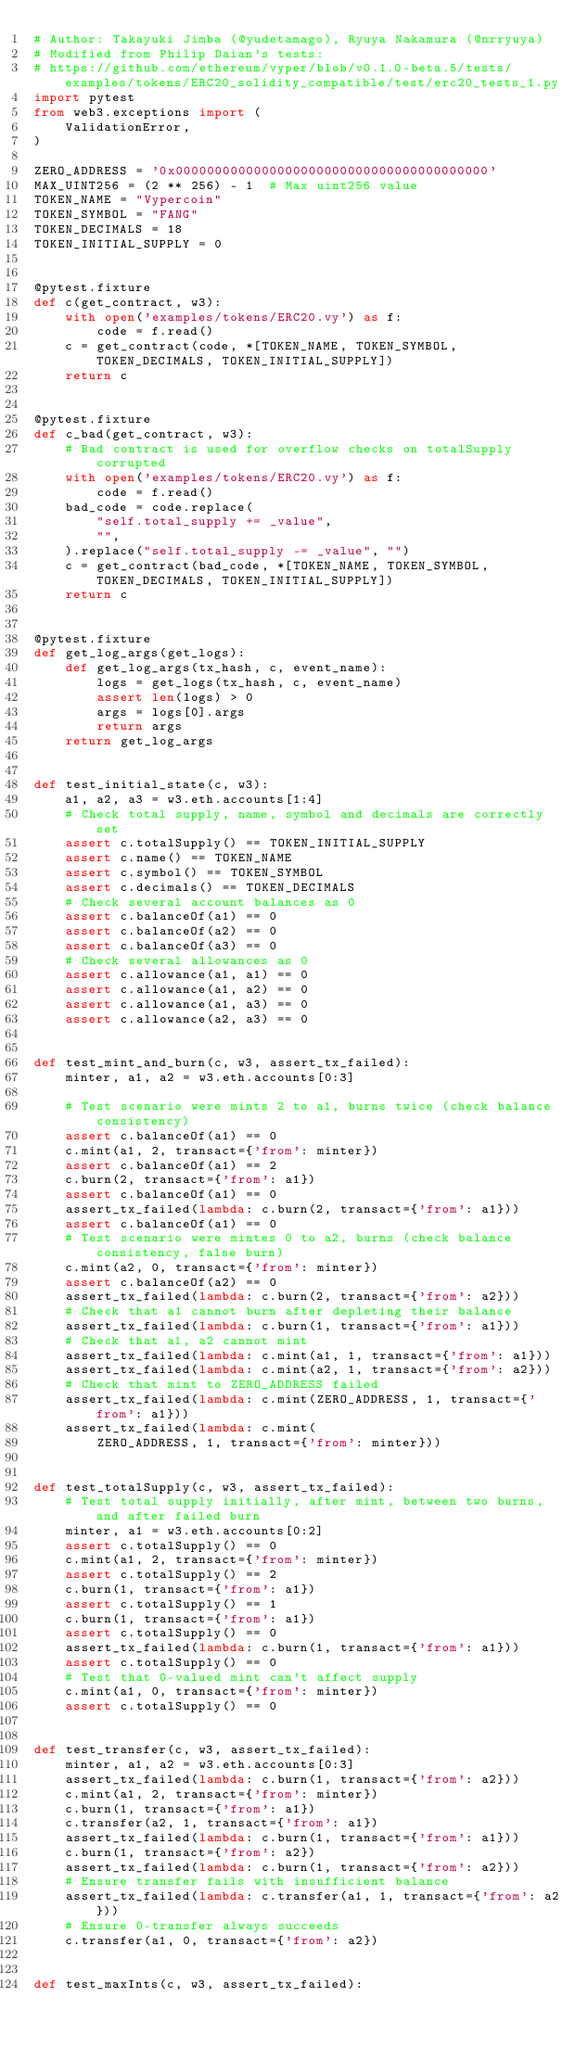<code> <loc_0><loc_0><loc_500><loc_500><_Python_># Author: Takayuki Jimba (@yudetamago), Ryuya Nakamura (@nrryuya)
# Modified from Philip Daian's tests:
# https://github.com/ethereum/vyper/blob/v0.1.0-beta.5/tests/examples/tokens/ERC20_solidity_compatible/test/erc20_tests_1.py
import pytest
from web3.exceptions import (
    ValidationError,
)

ZERO_ADDRESS = '0x0000000000000000000000000000000000000000'
MAX_UINT256 = (2 ** 256) - 1  # Max uint256 value
TOKEN_NAME = "Vypercoin"
TOKEN_SYMBOL = "FANG"
TOKEN_DECIMALS = 18
TOKEN_INITIAL_SUPPLY = 0


@pytest.fixture
def c(get_contract, w3):
    with open('examples/tokens/ERC20.vy') as f:
        code = f.read()
    c = get_contract(code, *[TOKEN_NAME, TOKEN_SYMBOL, TOKEN_DECIMALS, TOKEN_INITIAL_SUPPLY])
    return c


@pytest.fixture
def c_bad(get_contract, w3):
    # Bad contract is used for overflow checks on totalSupply corrupted
    with open('examples/tokens/ERC20.vy') as f:
        code = f.read()
    bad_code = code.replace(
        "self.total_supply += _value",
        "",
    ).replace("self.total_supply -= _value", "")
    c = get_contract(bad_code, *[TOKEN_NAME, TOKEN_SYMBOL, TOKEN_DECIMALS, TOKEN_INITIAL_SUPPLY])
    return c


@pytest.fixture
def get_log_args(get_logs):
    def get_log_args(tx_hash, c, event_name):
        logs = get_logs(tx_hash, c, event_name)
        assert len(logs) > 0
        args = logs[0].args
        return args
    return get_log_args


def test_initial_state(c, w3):
    a1, a2, a3 = w3.eth.accounts[1:4]
    # Check total supply, name, symbol and decimals are correctly set
    assert c.totalSupply() == TOKEN_INITIAL_SUPPLY
    assert c.name() == TOKEN_NAME
    assert c.symbol() == TOKEN_SYMBOL
    assert c.decimals() == TOKEN_DECIMALS
    # Check several account balances as 0
    assert c.balanceOf(a1) == 0
    assert c.balanceOf(a2) == 0
    assert c.balanceOf(a3) == 0
    # Check several allowances as 0
    assert c.allowance(a1, a1) == 0
    assert c.allowance(a1, a2) == 0
    assert c.allowance(a1, a3) == 0
    assert c.allowance(a2, a3) == 0


def test_mint_and_burn(c, w3, assert_tx_failed):
    minter, a1, a2 = w3.eth.accounts[0:3]

    # Test scenario were mints 2 to a1, burns twice (check balance consistency)
    assert c.balanceOf(a1) == 0
    c.mint(a1, 2, transact={'from': minter})
    assert c.balanceOf(a1) == 2
    c.burn(2, transact={'from': a1})
    assert c.balanceOf(a1) == 0
    assert_tx_failed(lambda: c.burn(2, transact={'from': a1}))
    assert c.balanceOf(a1) == 0
    # Test scenario were mintes 0 to a2, burns (check balance consistency, false burn)
    c.mint(a2, 0, transact={'from': minter})
    assert c.balanceOf(a2) == 0
    assert_tx_failed(lambda: c.burn(2, transact={'from': a2}))
    # Check that a1 cannot burn after depleting their balance
    assert_tx_failed(lambda: c.burn(1, transact={'from': a1}))
    # Check that a1, a2 cannot mint
    assert_tx_failed(lambda: c.mint(a1, 1, transact={'from': a1}))
    assert_tx_failed(lambda: c.mint(a2, 1, transact={'from': a2}))
    # Check that mint to ZERO_ADDRESS failed
    assert_tx_failed(lambda: c.mint(ZERO_ADDRESS, 1, transact={'from': a1}))
    assert_tx_failed(lambda: c.mint(
        ZERO_ADDRESS, 1, transact={'from': minter}))


def test_totalSupply(c, w3, assert_tx_failed):
    # Test total supply initially, after mint, between two burns, and after failed burn
    minter, a1 = w3.eth.accounts[0:2]
    assert c.totalSupply() == 0
    c.mint(a1, 2, transact={'from': minter})
    assert c.totalSupply() == 2
    c.burn(1, transact={'from': a1})
    assert c.totalSupply() == 1
    c.burn(1, transact={'from': a1})
    assert c.totalSupply() == 0
    assert_tx_failed(lambda: c.burn(1, transact={'from': a1}))
    assert c.totalSupply() == 0
    # Test that 0-valued mint can't affect supply
    c.mint(a1, 0, transact={'from': minter})
    assert c.totalSupply() == 0


def test_transfer(c, w3, assert_tx_failed):
    minter, a1, a2 = w3.eth.accounts[0:3]
    assert_tx_failed(lambda: c.burn(1, transact={'from': a2}))
    c.mint(a1, 2, transact={'from': minter})
    c.burn(1, transact={'from': a1})
    c.transfer(a2, 1, transact={'from': a1})
    assert_tx_failed(lambda: c.burn(1, transact={'from': a1}))
    c.burn(1, transact={'from': a2})
    assert_tx_failed(lambda: c.burn(1, transact={'from': a2}))
    # Ensure transfer fails with insufficient balance
    assert_tx_failed(lambda: c.transfer(a1, 1, transact={'from': a2}))
    # Ensure 0-transfer always succeeds
    c.transfer(a1, 0, transact={'from': a2})


def test_maxInts(c, w3, assert_tx_failed):</code> 